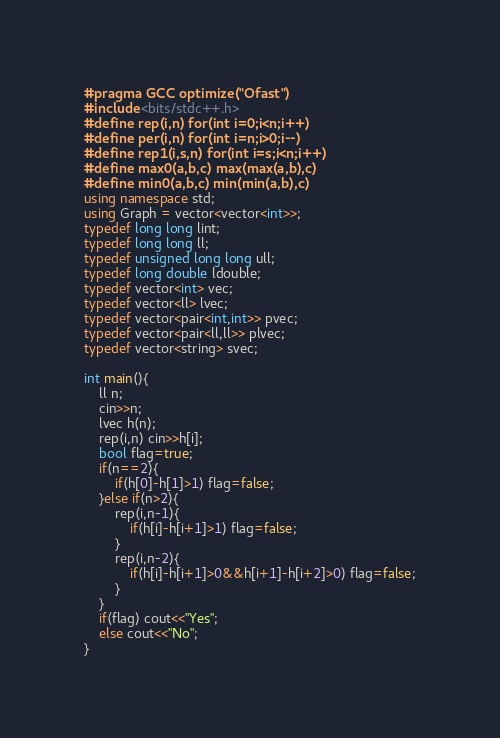Convert code to text. <code><loc_0><loc_0><loc_500><loc_500><_C++_>#pragma GCC optimize("Ofast")
#include <bits/stdc++.h>
#define rep(i,n) for(int i=0;i<n;i++)
#define per(i,n) for(int i=n;i>0;i--)
#define rep1(i,s,n) for(int i=s;i<n;i++)
#define max0(a,b,c) max(max(a,b),c)
#define min0(a,b,c) min(min(a,b),c) 
using namespace std;
using Graph = vector<vector<int>>;
typedef long long lint;
typedef long long ll;
typedef unsigned long long ull;
typedef long double ldouble;
typedef vector<int> vec;
typedef vector<ll> lvec;
typedef vector<pair<int,int>> pvec;
typedef vector<pair<ll,ll>> plvec;
typedef vector<string> svec;

int main(){
    ll n;
    cin>>n;
    lvec h(n);
    rep(i,n) cin>>h[i];
    bool flag=true;
    if(n==2){
        if(h[0]-h[1]>1) flag=false;
    }else if(n>2){
        rep(i,n-1){
            if(h[i]-h[i+1]>1) flag=false;
        }
        rep(i,n-2){
            if(h[i]-h[i+1]>0&&h[i+1]-h[i+2]>0) flag=false;
        }
    }
    if(flag) cout<<"Yes";
    else cout<<"No";
}</code> 